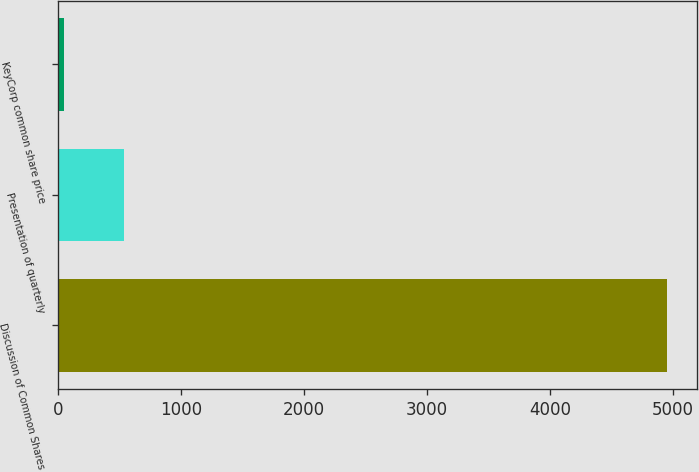Convert chart. <chart><loc_0><loc_0><loc_500><loc_500><bar_chart><fcel>Discussion of Common Shares<fcel>Presentation of quarterly<fcel>KeyCorp common share price<nl><fcel>4950<fcel>539.1<fcel>49<nl></chart> 